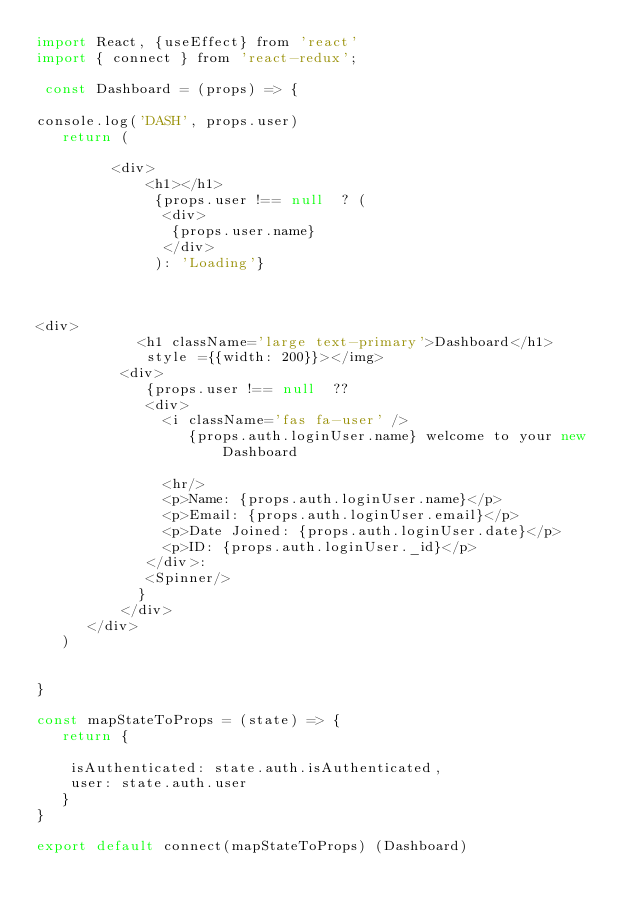<code> <loc_0><loc_0><loc_500><loc_500><_JavaScript_>import React, {useEffect} from 'react'
import { connect } from 'react-redux';

 const Dashboard = (props) => {
  
console.log('DASH', props.user)
   return (
        
         <div>
             <h1></h1>
              {props.user !== null  ? (
               <div>
                {props.user.name}
               </div>
              ): 'Loading'}

           

<div>
            <h1 className='large text-primary'>Dashboard</h1>
             style ={{width: 200}}></img>
          <div>
             {props.user !== null  ?? 
             <div>
               <i className='fas fa-user' />  
                  {props.auth.loginUser.name} welcome to your new Dashboard 
                  
               <hr/>
               <p>Name: {props.auth.loginUser.name}</p>
               <p>Email: {props.auth.loginUser.email}</p>
               <p>Date Joined: {props.auth.loginUser.date}</p>
               <p>ID: {props.auth.loginUser._id}</p>
             </div>: 
             <Spinner/>
            }
          </div>
      </div>
   )

   
}

const mapStateToProps = (state) => {
   return {
      
    isAuthenticated: state.auth.isAuthenticated,
    user: state.auth.user
   }
}

export default connect(mapStateToProps) (Dashboard)
</code> 